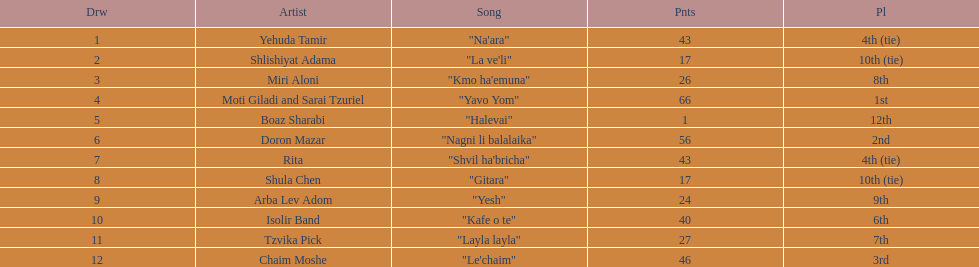Can you identify the song that comes immediately before "yesh"? "Gitara". 